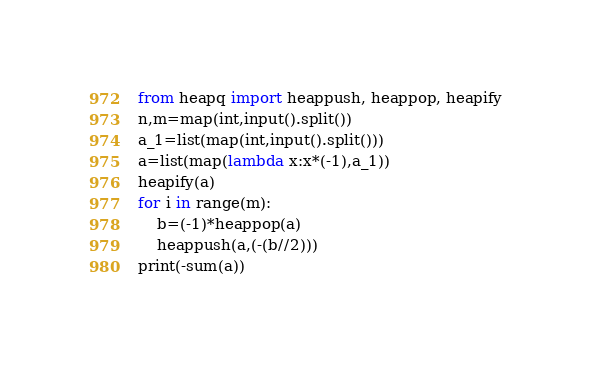<code> <loc_0><loc_0><loc_500><loc_500><_Python_>from heapq import heappush, heappop, heapify
n,m=map(int,input().split())
a_1=list(map(int,input().split()))
a=list(map(lambda x:x*(-1),a_1))
heapify(a)
for i in range(m):
    b=(-1)*heappop(a)
    heappush(a,(-(b//2)))
print(-sum(a))</code> 